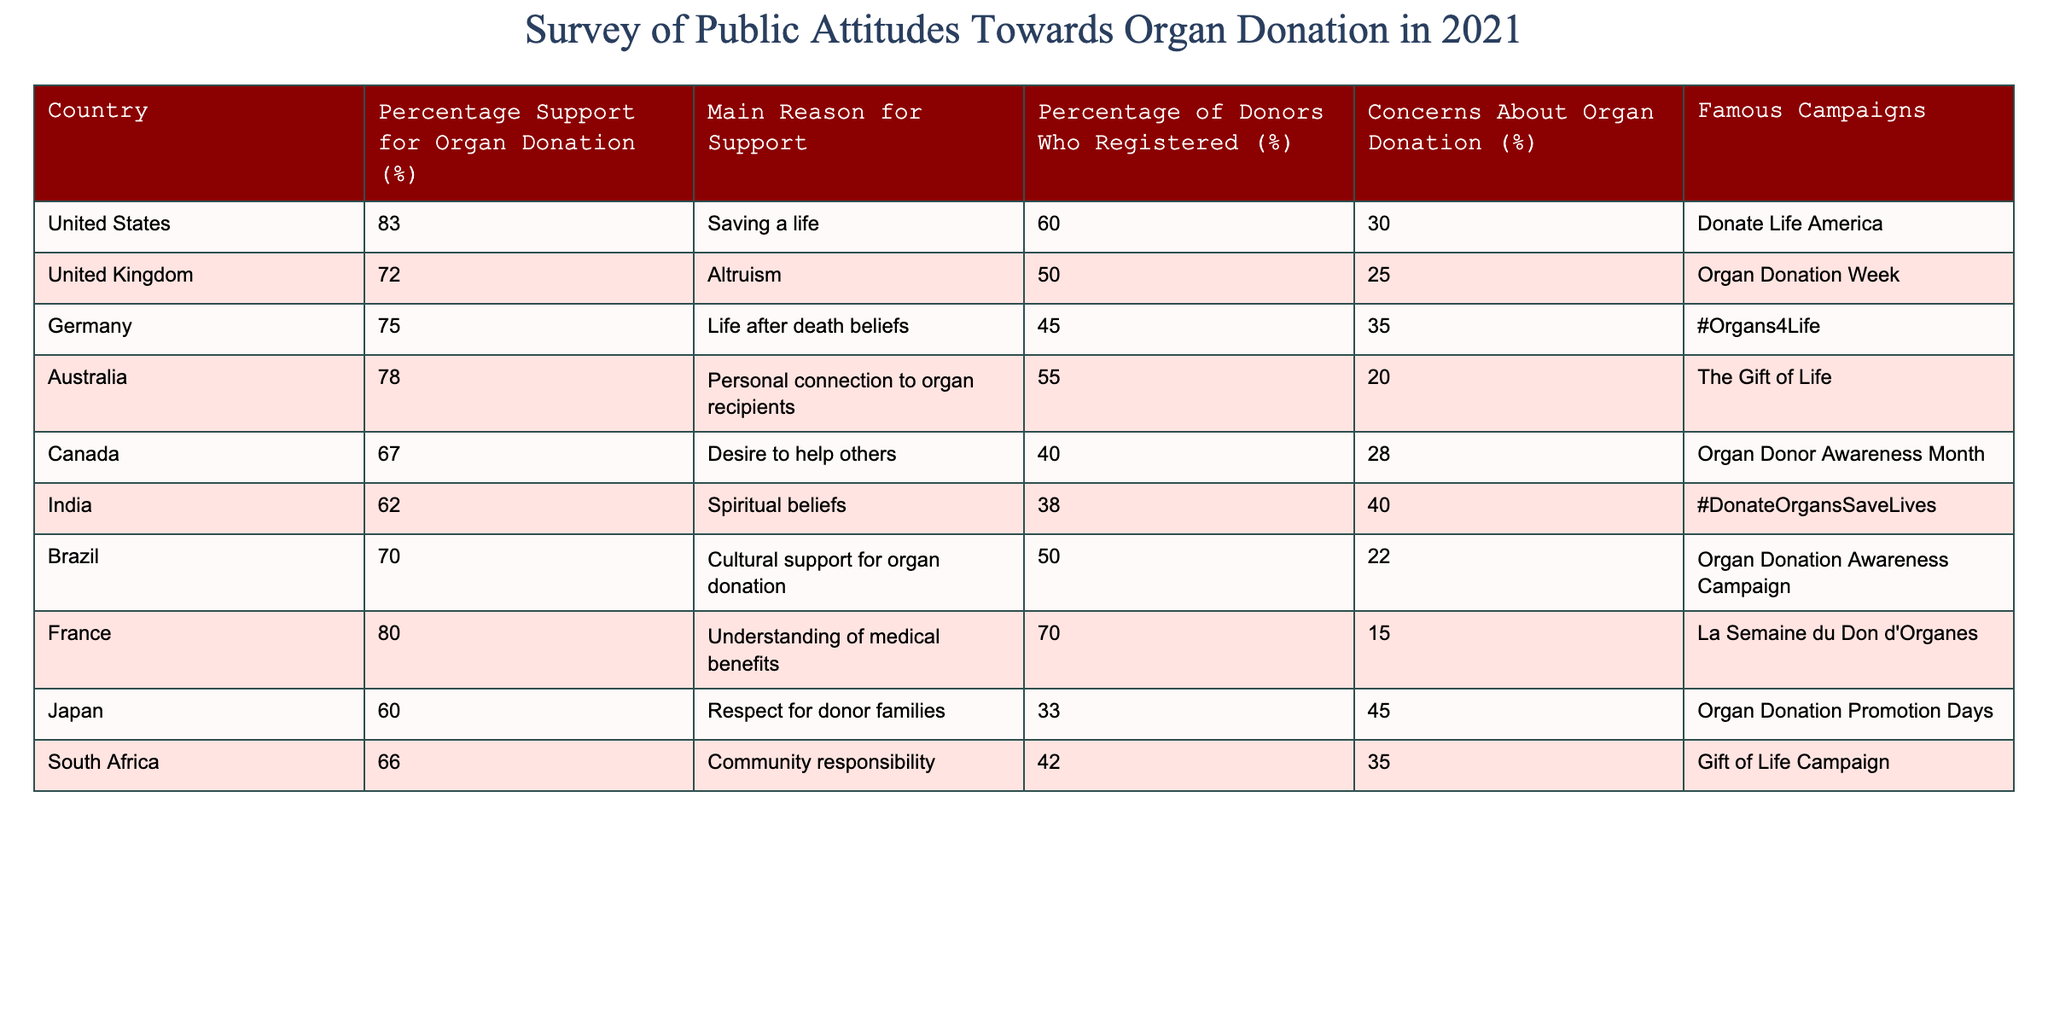What's the percentage of support for organ donation in Canada? According to the table, Canada has a support percentage of 67% for organ donation.
Answer: 67% Which country has the highest percentage of donors who registered? By examining the "Percentage of Donors Who Registered" column, France has the highest percentage at 70%.
Answer: 70% What is the main reason for support in Australia? The table specifies that the main reason for support for organ donation in Australia is a personal connection to organ recipients.
Answer: Personal connection to organ recipients True or false: The percentage of people with concerns about organ donation in India is higher than in Canada. In the table, the concerns about organ donation in India is 40%, while in Canada it is 28%. Thus, the statement is true.
Answer: True Which country has the biggest difference between the percentage support for organ donation and the percentage of donors who registered? To find this, we subtract the "Percentage of Donors Who Registered" from the "Percentage Support for Organ Donation" for each country and identify the largest difference: 
- United States: 83 - 60 = 23
- United Kingdom: 72 - 50 = 22
- Germany: 75 - 45 = 30
- Australia: 78 - 55 = 23
- Canada: 67 - 40 = 27
- India: 62 - 38 = 24
- Brazil: 70 - 50 = 20
- France: 80 - 70 = 10
- Japan: 60 - 33 = 27
- South Africa: 66 - 42 = 24
The country with the biggest difference is Germany with a difference of 30%.
Answer: Germany How does the percentage support for organ donation in the UK compare to Japan? The percentage support for organ donation in the UK is 72%, while in Japan it is 60%. Thus, the UK has a higher support percentage by 12%.
Answer: UK is higher by 12% What percentage of people in South Africa are concerned about organ donation? The table states that 35% of people in South Africa have concerns about organ donation.
Answer: 35% Which country has the least percentage of donors who registered? By looking at the "Percentage of Donors Who Registered" column, India has the least percentage at 38%.
Answer: 38% 